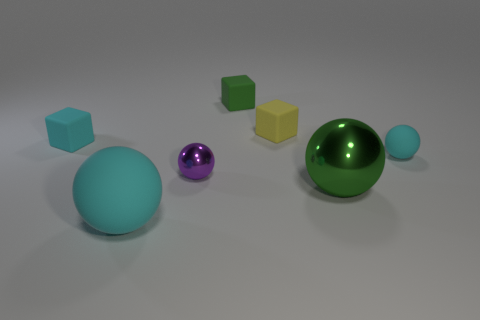Add 3 tiny blue matte things. How many objects exist? 10 Subtract all cubes. How many objects are left? 4 Subtract all tiny purple cubes. Subtract all big rubber spheres. How many objects are left? 6 Add 6 cyan matte blocks. How many cyan matte blocks are left? 7 Add 6 large cyan metallic spheres. How many large cyan metallic spheres exist? 6 Subtract 1 green cubes. How many objects are left? 6 